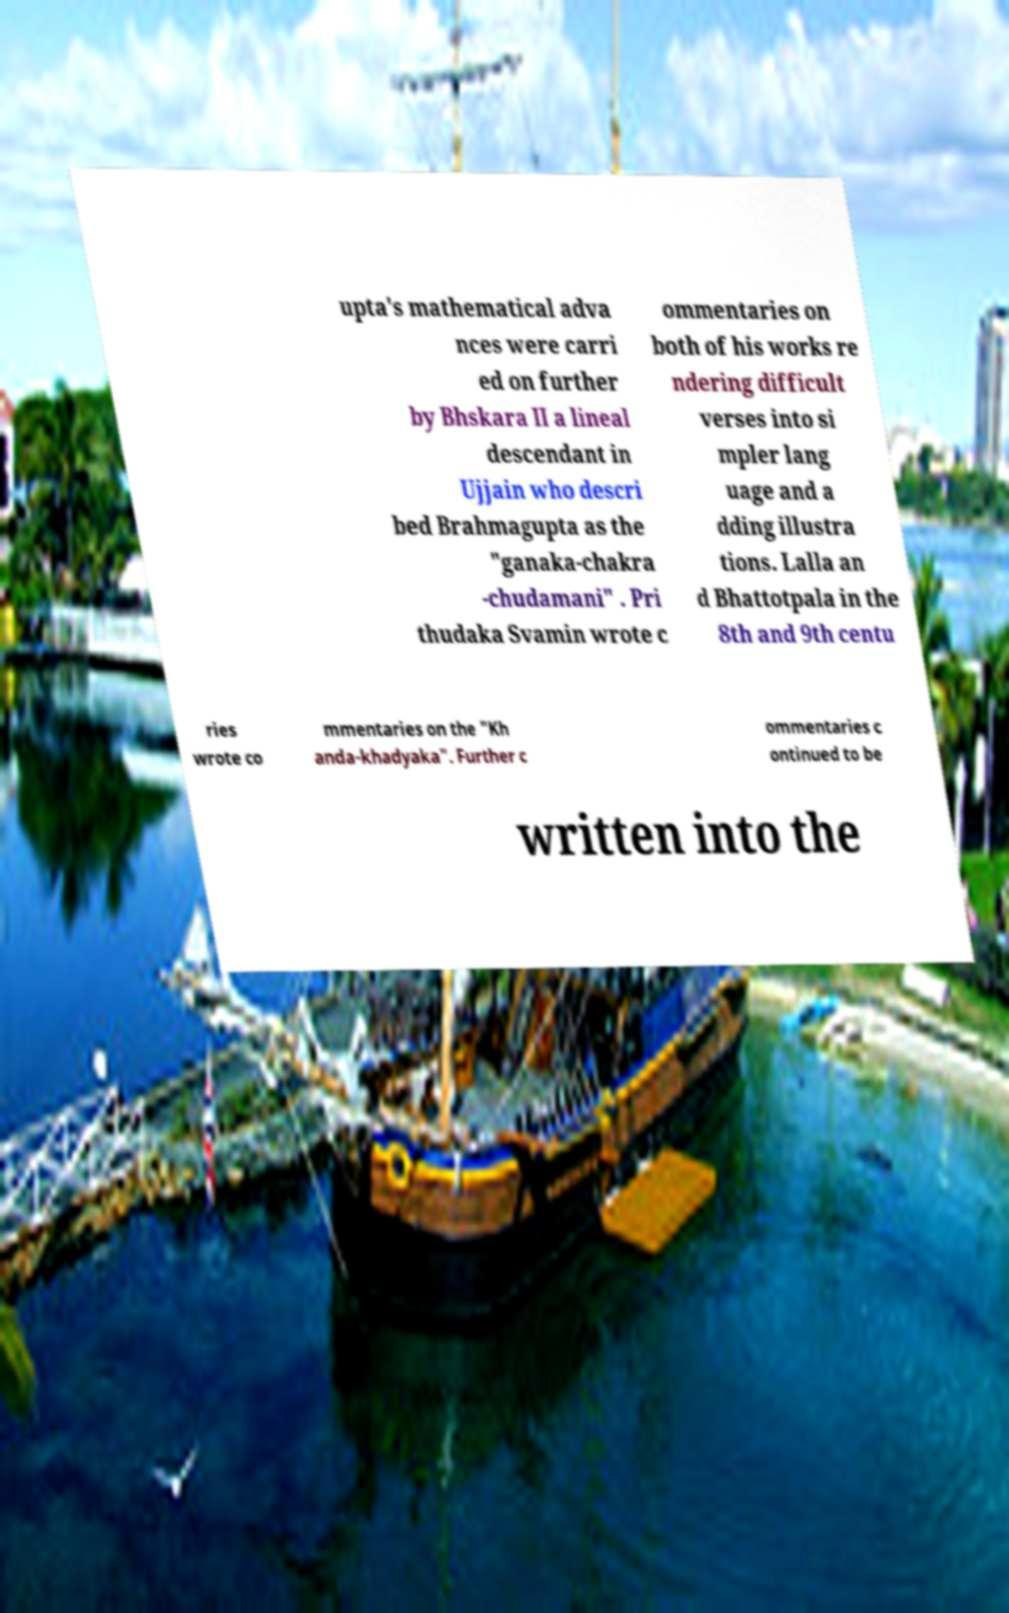Could you assist in decoding the text presented in this image and type it out clearly? upta's mathematical adva nces were carri ed on further by Bhskara II a lineal descendant in Ujjain who descri bed Brahmagupta as the "ganaka-chakra -chudamani" . Pri thudaka Svamin wrote c ommentaries on both of his works re ndering difficult verses into si mpler lang uage and a dding illustra tions. Lalla an d Bhattotpala in the 8th and 9th centu ries wrote co mmentaries on the "Kh anda-khadyaka". Further c ommentaries c ontinued to be written into the 